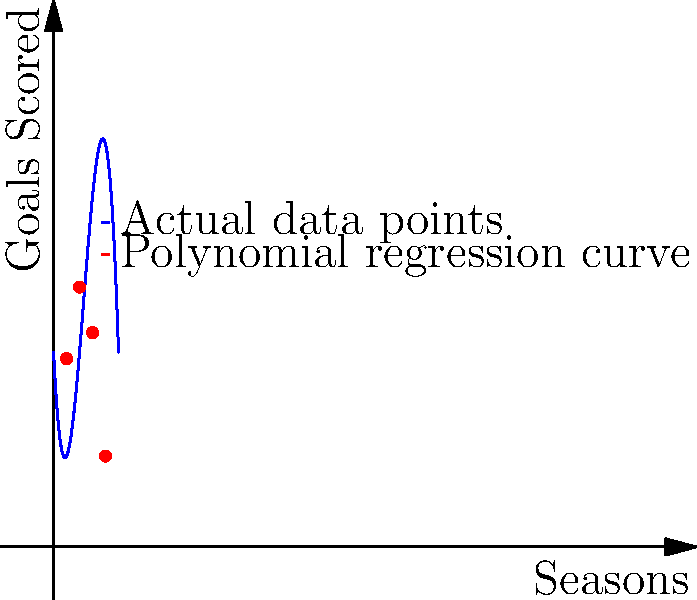The graph shows a polynomial regression analysis of your goal-scoring trend over 10 seasons with the Marconi Stallions FC. Given that the regression curve is represented by the function $f(x) = -0.5x^3 + 7x^2 - 20x + 30$, where $x$ represents the season number and $f(x)$ represents the number of goals scored, in which season did you likely reach your peak goal-scoring performance? To find the season with the peak goal-scoring performance, we need to follow these steps:

1) The peak of the curve represents the maximum number of goals scored in a season.

2) To find the maximum point of the polynomial function, we need to find where its derivative equals zero:
   $f'(x) = -1.5x^2 + 14x - 20$

3) Set $f'(x) = 0$ and solve for $x$:
   $-1.5x^2 + 14x - 20 = 0$

4) This is a quadratic equation. We can solve it using the quadratic formula:
   $x = \frac{-b \pm \sqrt{b^2 - 4ac}}{2a}$

   Where $a = -1.5$, $b = 14$, and $c = -20$

5) Plugging in these values:
   $x = \frac{-14 \pm \sqrt{14^2 - 4(-1.5)(-20)}}{2(-1.5)}$

6) Solving this gives us two solutions: $x ≈ 4.67$ and $x ≈ 2.67$

7) Since we're looking for a maximum, we choose the larger value: $x ≈ 4.67$

8) As we're dealing with seasons, which are whole numbers, we round this to the nearest integer: 5.

Therefore, the peak goal-scoring performance was likely reached in season 5.
Answer: Season 5 